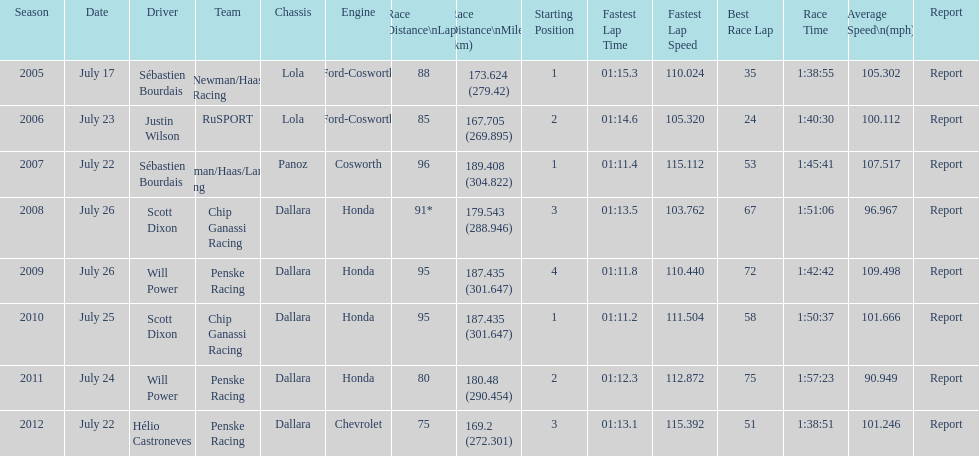Parse the table in full. {'header': ['Season', 'Date', 'Driver', 'Team', 'Chassis', 'Engine', 'Race Distance\\nLaps', 'Race Distance\\nMiles (km)', 'Starting Position', 'Fastest Lap Time', 'Fastest Lap Speed', 'Best Race Lap', 'Race Time', 'Average Speed\\n(mph)', 'Report'], 'rows': [['2005', 'July 17', 'Sébastien Bourdais', 'Newman/Haas Racing', 'Lola', 'Ford-Cosworth', '88', '173.624 (279.42)', '1', '01:15.3', '110.024', '35', '1:38:55', '105.302', 'Report'], ['2006', 'July 23', 'Justin Wilson', 'RuSPORT', 'Lola', 'Ford-Cosworth', '85', '167.705 (269.895)', '2', '01:14.6', '105.320', '24', '1:40:30', '100.112', 'Report'], ['2007', 'July 22', 'Sébastien Bourdais', 'Newman/Haas/Lanigan Racing', 'Panoz', 'Cosworth', '96', '189.408 (304.822)', '1', '01:11.4', '115.112', '53', '1:45:41', '107.517', 'Report'], ['2008', 'July 26', 'Scott Dixon', 'Chip Ganassi Racing', 'Dallara', 'Honda', '91*', '179.543 (288.946)', '3', '01:13.5', '103.762', '67', '1:51:06', '96.967', 'Report'], ['2009', 'July 26', 'Will Power', 'Penske Racing', 'Dallara', 'Honda', '95', '187.435 (301.647)', '4', '01:11.8', '110.440', '72', '1:42:42', '109.498', 'Report'], ['2010', 'July 25', 'Scott Dixon', 'Chip Ganassi Racing', 'Dallara', 'Honda', '95', '187.435 (301.647)', '1', '01:11.2', '111.504', '58', '1:50:37', '101.666', 'Report'], ['2011', 'July 24', 'Will Power', 'Penske Racing', 'Dallara', 'Honda', '80', '180.48 (290.454)', '2', '01:12.3', '112.872', '75', '1:57:23', '90.949', 'Report'], ['2012', 'July 22', 'Hélio Castroneves', 'Penske Racing', 'Dallara', 'Chevrolet', '75', '169.2 (272.301)', '3', '01:13.1', '115.392', '51', '1:38:51', '101.246', 'Report']]} How many times did sébastien bourdais win the champ car world series between 2005 and 2007? 2. 